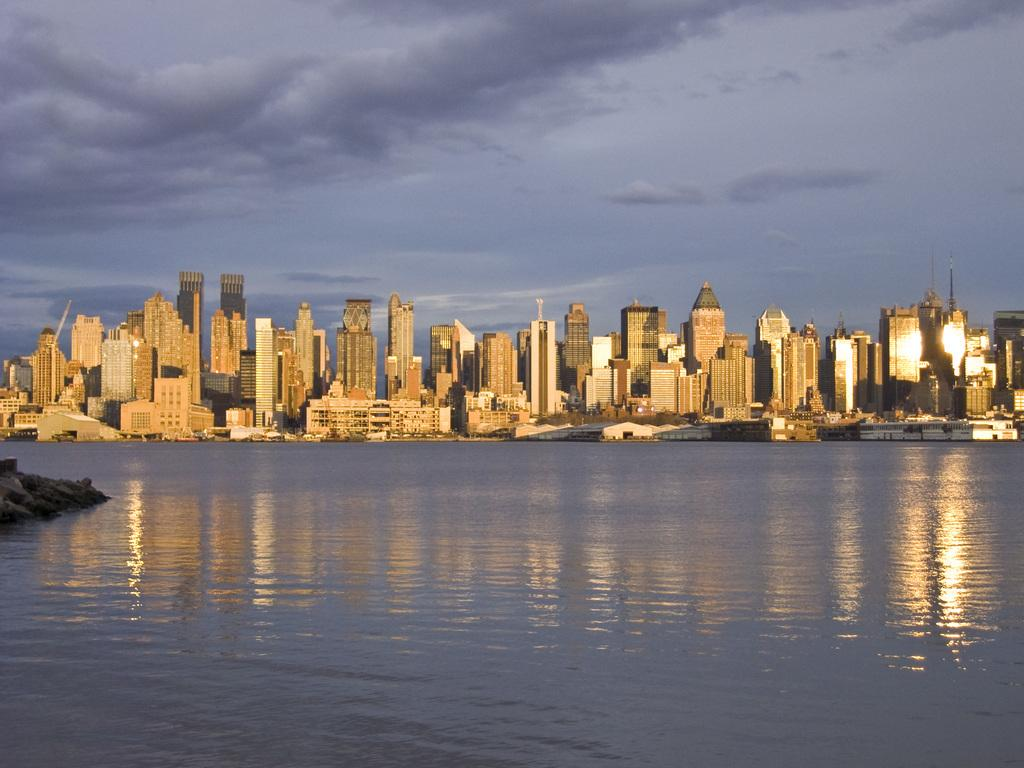What is the primary element visible in the image? There is water in the image. What can be seen in the background of the image? There are buildings and tower buildings in the background of the image. What is visible in the sky in the image? The sky is visible in the background of the image, and clouds are present. What language is the doctor speaking to the patient in the image? There is no doctor or patient present in the image; it features water, buildings, and clouds. 